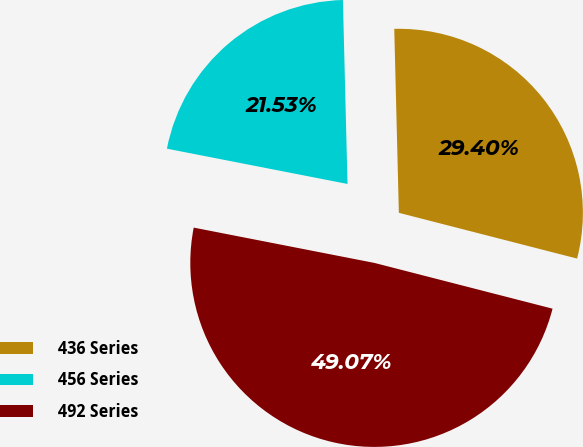<chart> <loc_0><loc_0><loc_500><loc_500><pie_chart><fcel>436 Series<fcel>456 Series<fcel>492 Series<nl><fcel>29.4%<fcel>21.53%<fcel>49.07%<nl></chart> 